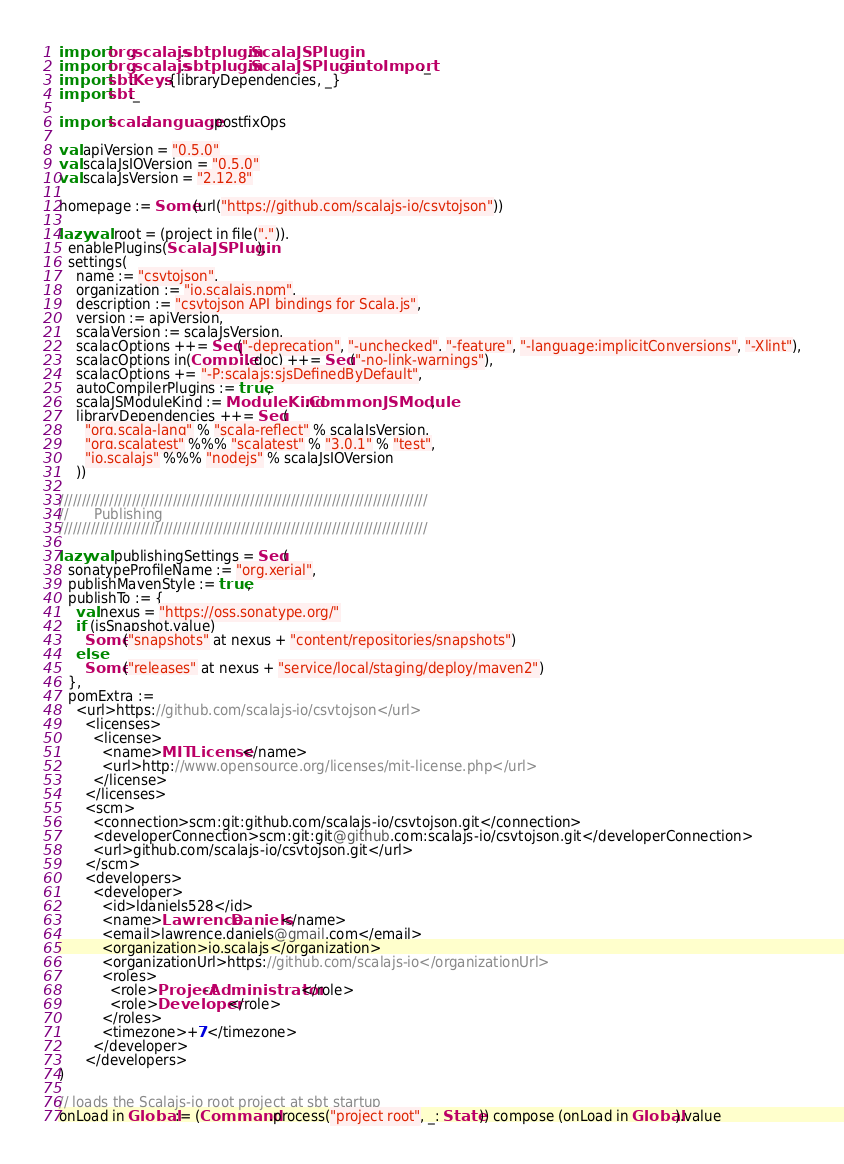<code> <loc_0><loc_0><loc_500><loc_500><_Scala_>import org.scalajs.sbtplugin.ScalaJSPlugin
import org.scalajs.sbtplugin.ScalaJSPlugin.autoImport._
import sbt.Keys.{libraryDependencies, _}
import sbt._

import scala.language.postfixOps

val apiVersion = "0.5.0"
val scalaJsIOVersion = "0.5.0"
val scalaJsVersion = "2.12.8"

homepage := Some(url("https://github.com/scalajs-io/csvtojson"))

lazy val root = (project in file(".")).
  enablePlugins(ScalaJSPlugin).
  settings(
    name := "csvtojson",
    organization := "io.scalajs.npm",
    description := "csvtojson API bindings for Scala.js",
    version := apiVersion,
    scalaVersion := scalaJsVersion,
    scalacOptions ++= Seq("-deprecation", "-unchecked", "-feature", "-language:implicitConversions", "-Xlint"),
    scalacOptions in(Compile, doc) ++= Seq("-no-link-warnings"),
    scalacOptions += "-P:scalajs:sjsDefinedByDefault",
    autoCompilerPlugins := true,
    scalaJSModuleKind := ModuleKind.CommonJSModule,
    libraryDependencies ++= Seq(
      "org.scala-lang" % "scala-reflect" % scalaJsVersion,
      "org.scalatest" %%% "scalatest" % "3.0.1" % "test",
      "io.scalajs" %%% "nodejs" % scalaJsIOVersion
    ))

/////////////////////////////////////////////////////////////////////////////////
//      Publishing
/////////////////////////////////////////////////////////////////////////////////

lazy val publishingSettings = Seq(
  sonatypeProfileName := "org.xerial",
  publishMavenStyle := true,
  publishTo := {
    val nexus = "https://oss.sonatype.org/"
    if (isSnapshot.value)
      Some("snapshots" at nexus + "content/repositories/snapshots")
    else
      Some("releases" at nexus + "service/local/staging/deploy/maven2")
  },
  pomExtra :=
    <url>https://github.com/scalajs-io/csvtojson</url>
      <licenses>
        <license>
          <name>MIT License</name>
          <url>http://www.opensource.org/licenses/mit-license.php</url>
        </license>
      </licenses>
      <scm>
        <connection>scm:git:github.com/scalajs-io/csvtojson.git</connection>
        <developerConnection>scm:git:git@github.com:scalajs-io/csvtojson.git</developerConnection>
        <url>github.com/scalajs-io/csvtojson.git</url>
      </scm>
      <developers>
        <developer>
          <id>ldaniels528</id>
          <name>Lawrence Daniels</name>
          <email>lawrence.daniels@gmail.com</email>
          <organization>io.scalajs</organization>
          <organizationUrl>https://github.com/scalajs-io</organizationUrl>
          <roles>
            <role>Project-Administrator</role>
            <role>Developer</role>
          </roles>
          <timezone>+7</timezone>
        </developer>
      </developers>
)

// loads the Scalajs-io root project at sbt startup
onLoad in Global := (Command.process("project root", _: State)) compose (onLoad in Global).value
</code> 